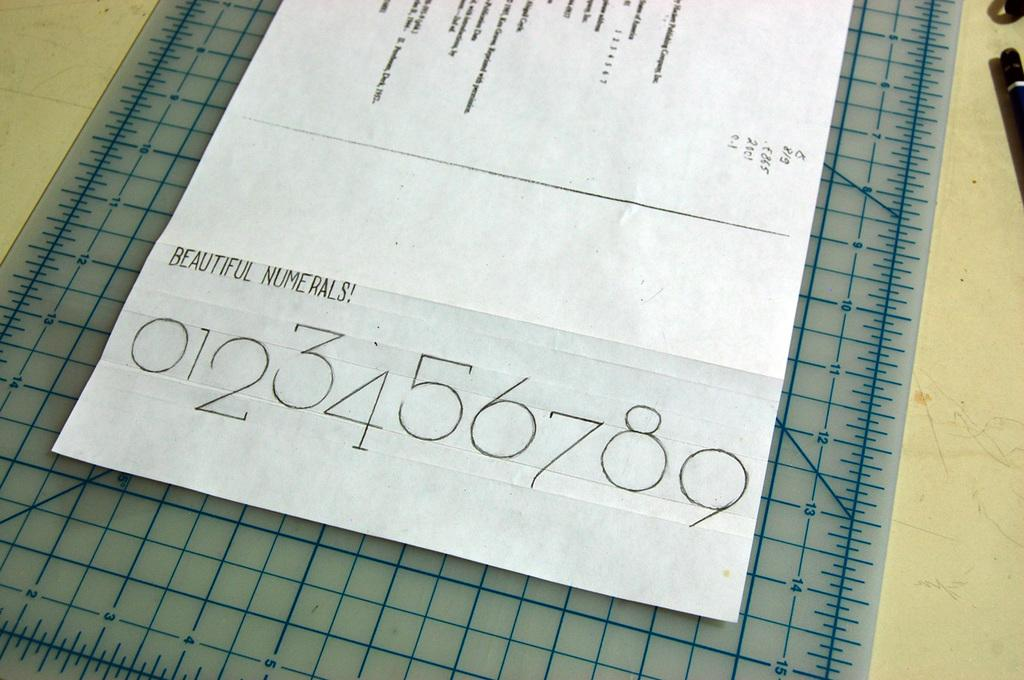<image>
Provide a brief description of the given image. a paper on top of a counter that says 'beautiful numerals!' on it 